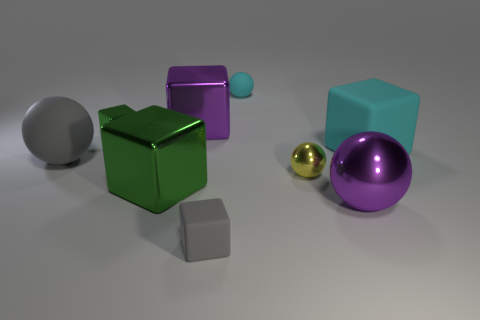What is the size of the rubber object that is the same color as the big matte ball?
Your answer should be compact. Small. What shape is the matte object that is the same color as the tiny rubber cube?
Your response must be concise. Sphere. Are there any other things that have the same color as the small rubber sphere?
Your answer should be compact. Yes. Do the big shiny sphere and the large shiny block that is behind the big green metal block have the same color?
Provide a succinct answer. Yes. Are there any other metallic objects that have the same shape as the tiny cyan thing?
Offer a terse response. Yes. Does the sphere to the left of the cyan rubber ball have the same size as the green block behind the yellow object?
Keep it short and to the point. No. Are there more big cyan matte objects than small cyan cylinders?
Offer a terse response. Yes. What number of tiny green cubes are the same material as the large cyan cube?
Your answer should be very brief. 0. Do the big cyan object and the small green metal object have the same shape?
Provide a succinct answer. Yes. What is the size of the matte thing behind the green shiny thing that is left of the green metal thing in front of the gray rubber sphere?
Provide a succinct answer. Small. 